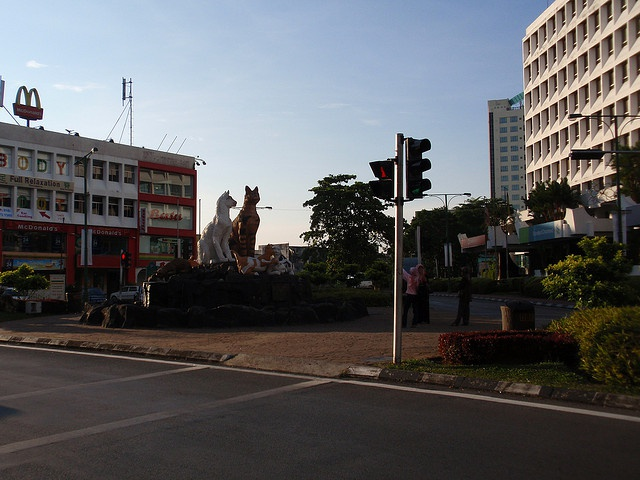Describe the objects in this image and their specific colors. I can see cat in lightblue, gray, and black tones, cat in lightblue, black, maroon, gray, and ivory tones, traffic light in lightblue, black, darkgray, gray, and maroon tones, people in lightblue, black, and purple tones, and traffic light in lightblue, black, maroon, gray, and lightgray tones in this image. 